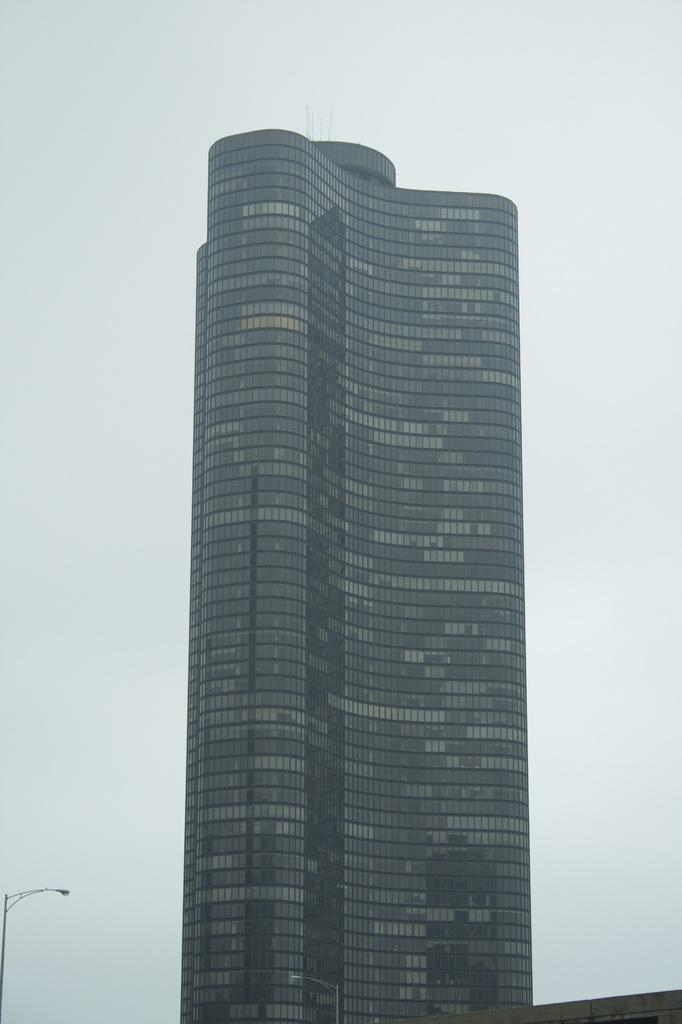What is the main subject in the center of the image? There is a building in the center of the image. What other objects can be seen at the bottom of the image? Electric light poles are visible at the bottom of the image. What part of the natural environment is visible in the image? The sky is visible in the background of the image. What type of lace can be seen on the building in the image? There is no lace present on the building in the image. How does the knowledge of the building's history contribute to the image? The provided facts do not mention any historical context or knowledge about the building, so it cannot be determined how this would contribute to the image. 